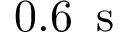<formula> <loc_0><loc_0><loc_500><loc_500>0 . 6 \, s</formula> 